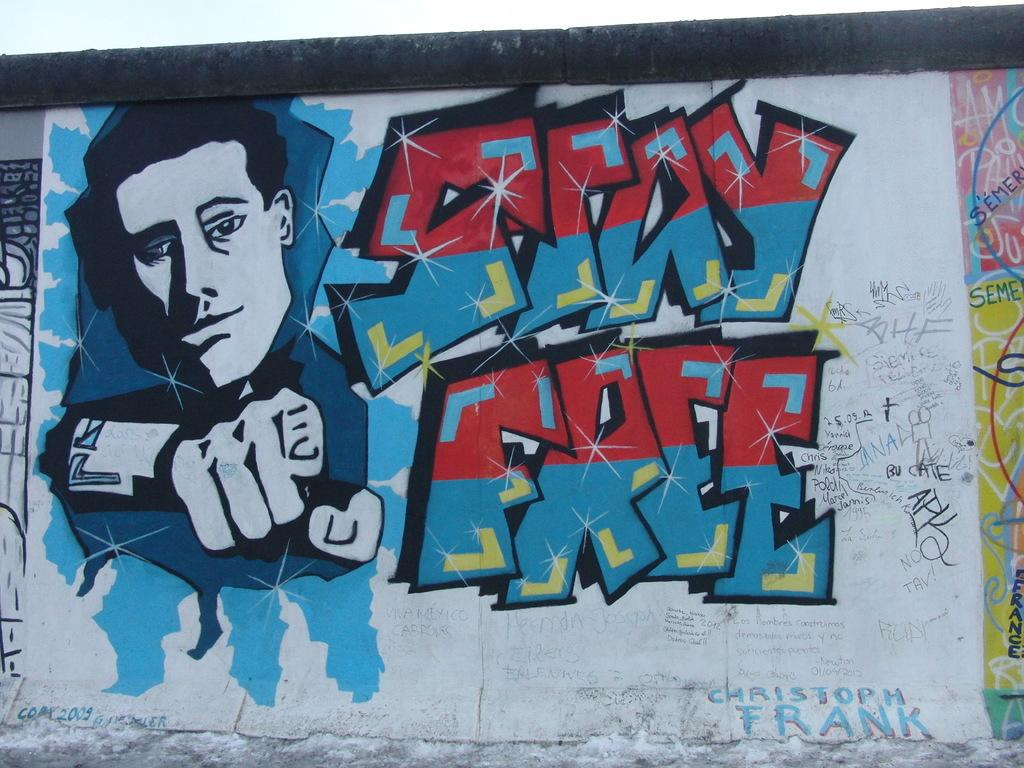<image>
Provide a brief description of the given image. Graffiti on a wall tells people to stay free. 